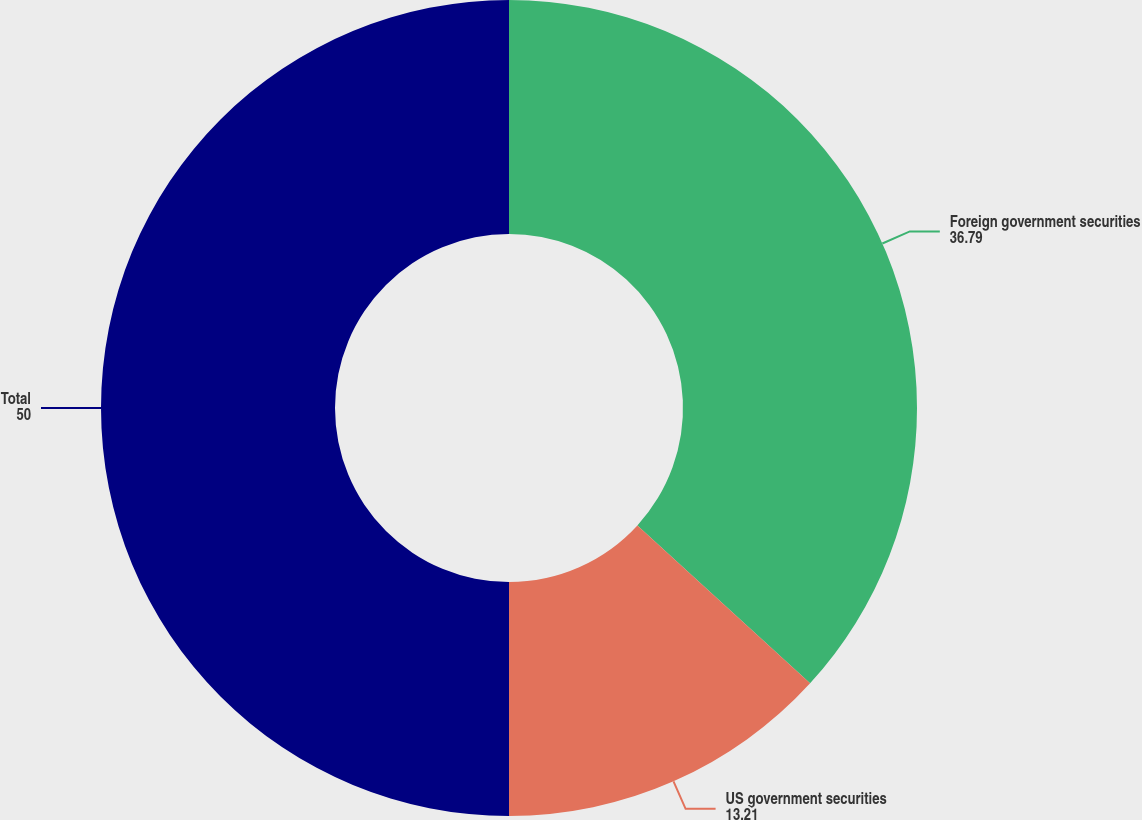<chart> <loc_0><loc_0><loc_500><loc_500><pie_chart><fcel>Foreign government securities<fcel>US government securities<fcel>Total<nl><fcel>36.79%<fcel>13.21%<fcel>50.0%<nl></chart> 